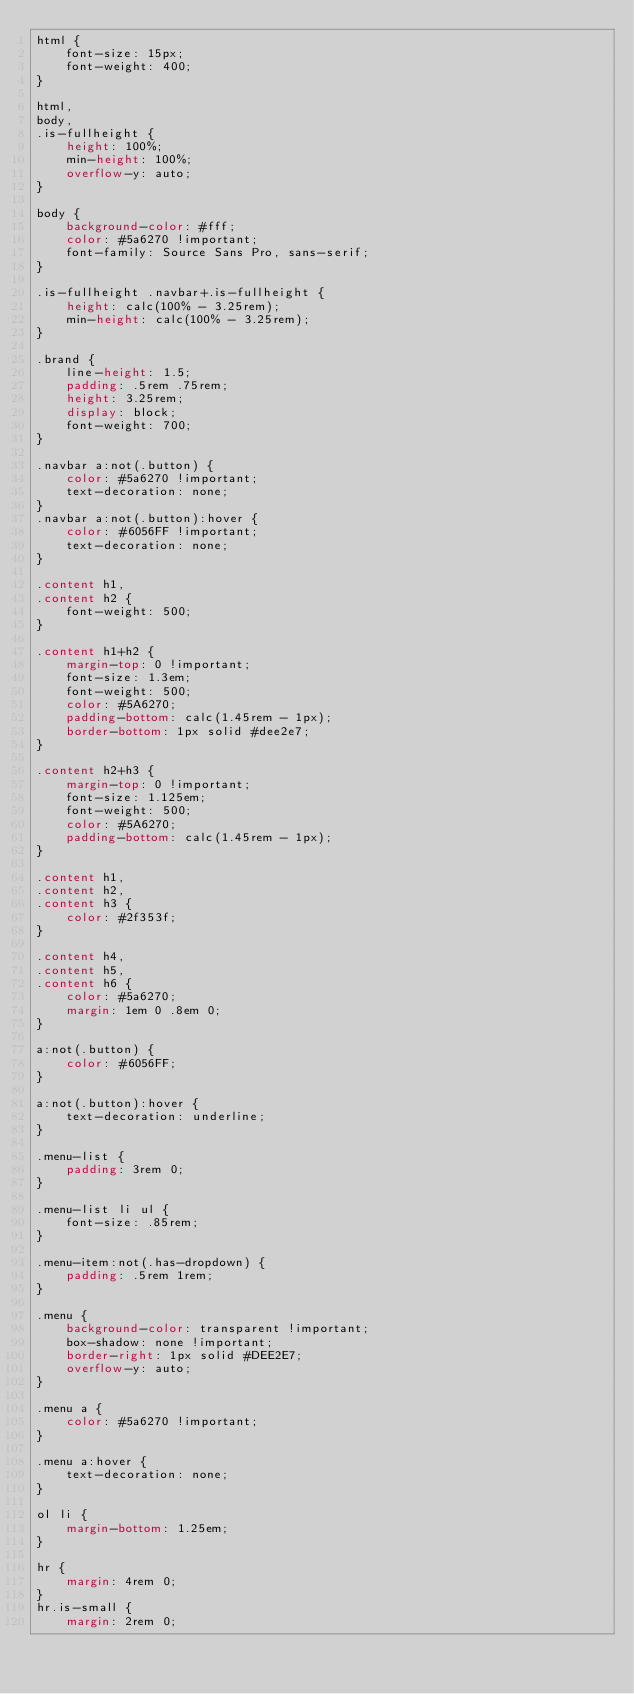<code> <loc_0><loc_0><loc_500><loc_500><_CSS_>html {
    font-size: 15px;
    font-weight: 400;
}

html,
body,
.is-fullheight {
    height: 100%;
    min-height: 100%;
    overflow-y: auto;
}

body {
    background-color: #fff;
    color: #5a6270 !important;
    font-family: Source Sans Pro, sans-serif;
}

.is-fullheight .navbar+.is-fullheight {
    height: calc(100% - 3.25rem);
    min-height: calc(100% - 3.25rem);
}

.brand {
    line-height: 1.5;
    padding: .5rem .75rem;
    height: 3.25rem;
    display: block;
    font-weight: 700;
}

.navbar a:not(.button) {
    color: #5a6270 !important;
    text-decoration: none;
}
.navbar a:not(.button):hover {
    color: #6056FF !important;
    text-decoration: none;
}

.content h1,
.content h2 {
    font-weight: 500;
}

.content h1+h2 {
    margin-top: 0 !important;
    font-size: 1.3em;
    font-weight: 500;
    color: #5A6270;
    padding-bottom: calc(1.45rem - 1px);
    border-bottom: 1px solid #dee2e7;
}

.content h2+h3 {
    margin-top: 0 !important;
    font-size: 1.125em;
    font-weight: 500;
    color: #5A6270;
    padding-bottom: calc(1.45rem - 1px);
}

.content h1,
.content h2,
.content h3 {
    color: #2f353f;
}

.content h4,
.content h5,
.content h6 {
    color: #5a6270;
    margin: 1em 0 .8em 0;
}

a:not(.button) {
    color: #6056FF;
}

a:not(.button):hover {
    text-decoration: underline;
}

.menu-list {
    padding: 3rem 0;
}

.menu-list li ul {
    font-size: .85rem;
}

.menu-item:not(.has-dropdown) {
    padding: .5rem 1rem;
}

.menu {
    background-color: transparent !important;
    box-shadow: none !important;
    border-right: 1px solid #DEE2E7;
    overflow-y: auto;
}

.menu a {
    color: #5a6270 !important;
}

.menu a:hover {
    text-decoration: none;
}

ol li {
    margin-bottom: 1.25em;
}

hr {
    margin: 4rem 0;
}
hr.is-small {
    margin: 2rem 0;</code> 